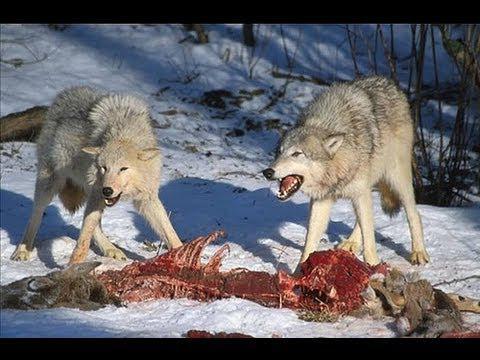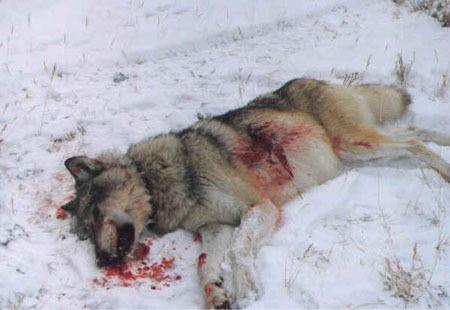The first image is the image on the left, the second image is the image on the right. Analyze the images presented: Is the assertion "wolves are feasting on a carcass" valid? Answer yes or no. Yes. 